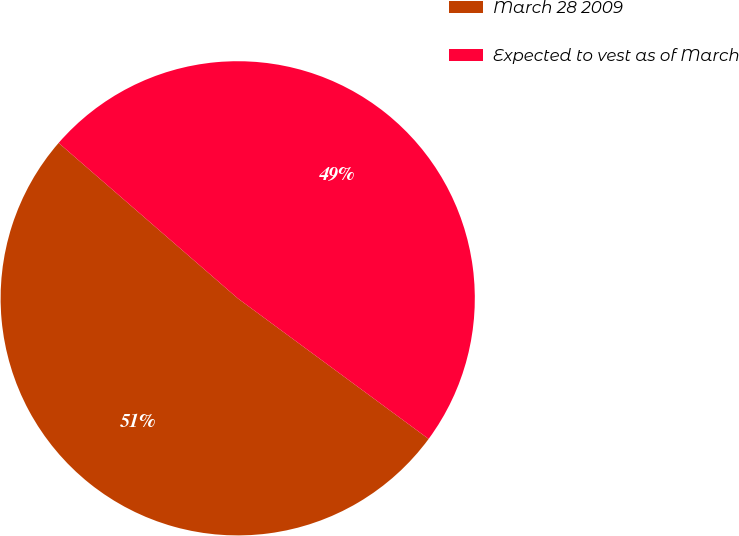Convert chart to OTSL. <chart><loc_0><loc_0><loc_500><loc_500><pie_chart><fcel>March 28 2009<fcel>Expected to vest as of March<nl><fcel>51.27%<fcel>48.73%<nl></chart> 